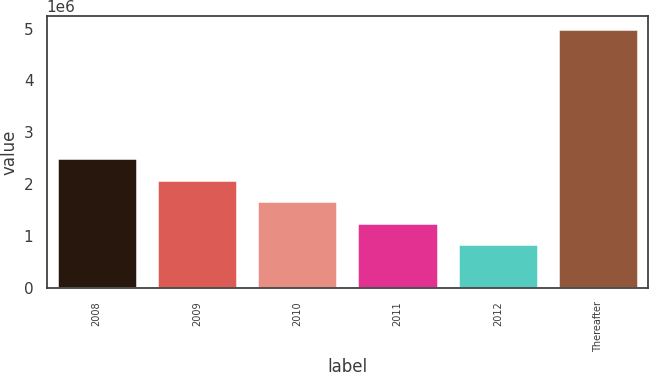Convert chart to OTSL. <chart><loc_0><loc_0><loc_500><loc_500><bar_chart><fcel>2008<fcel>2009<fcel>2010<fcel>2011<fcel>2012<fcel>Thereafter<nl><fcel>2.50242e+06<fcel>2.08793e+06<fcel>1.67343e+06<fcel>1.25893e+06<fcel>844426<fcel>4.98942e+06<nl></chart> 